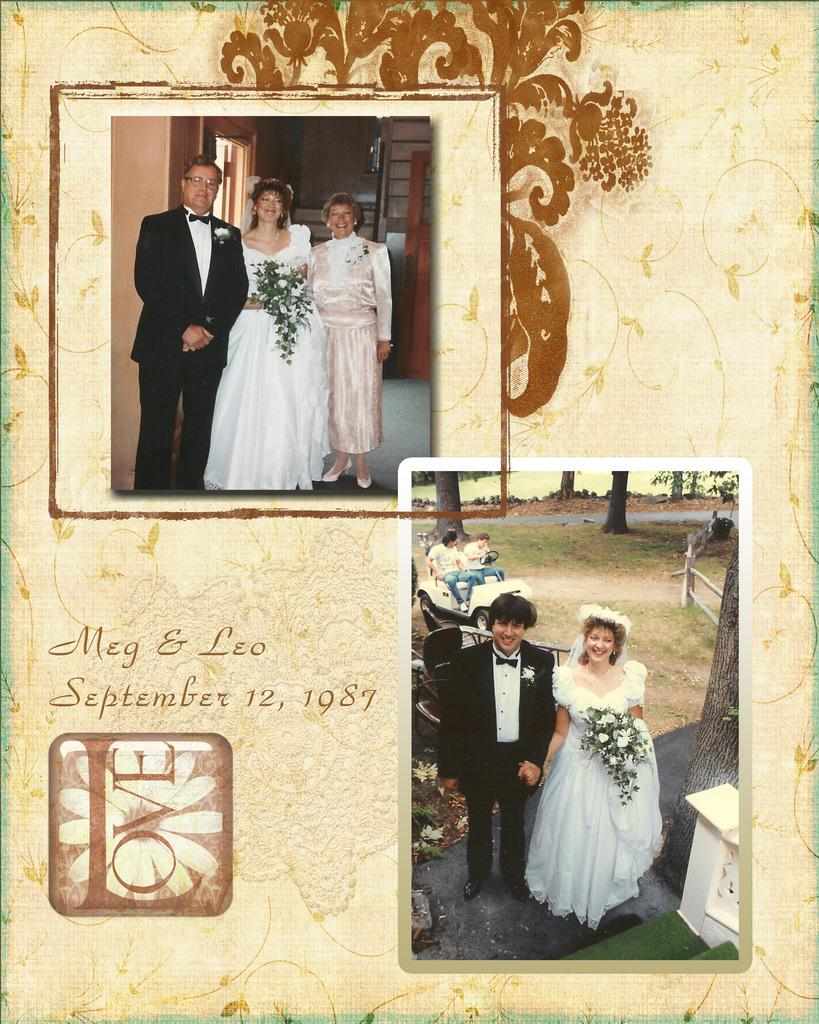What type of posters are featured in the image? There are two college photography posters in the image. What subjects are depicted in the posters? Each poster features a bride and groom. How are the bride and groom positioned in the posters? The bride and groom are standing in front in each poster. What are the bride and groom doing in the posters? The bride and groom are posing for a camera in each poster. What is the tax rate for the wedding depicted in the image? There is no information about tax rates in the image; it features college photography posters with bride and groom subjects. Can you see a robin in the image? No, there is no robin present in the image. 